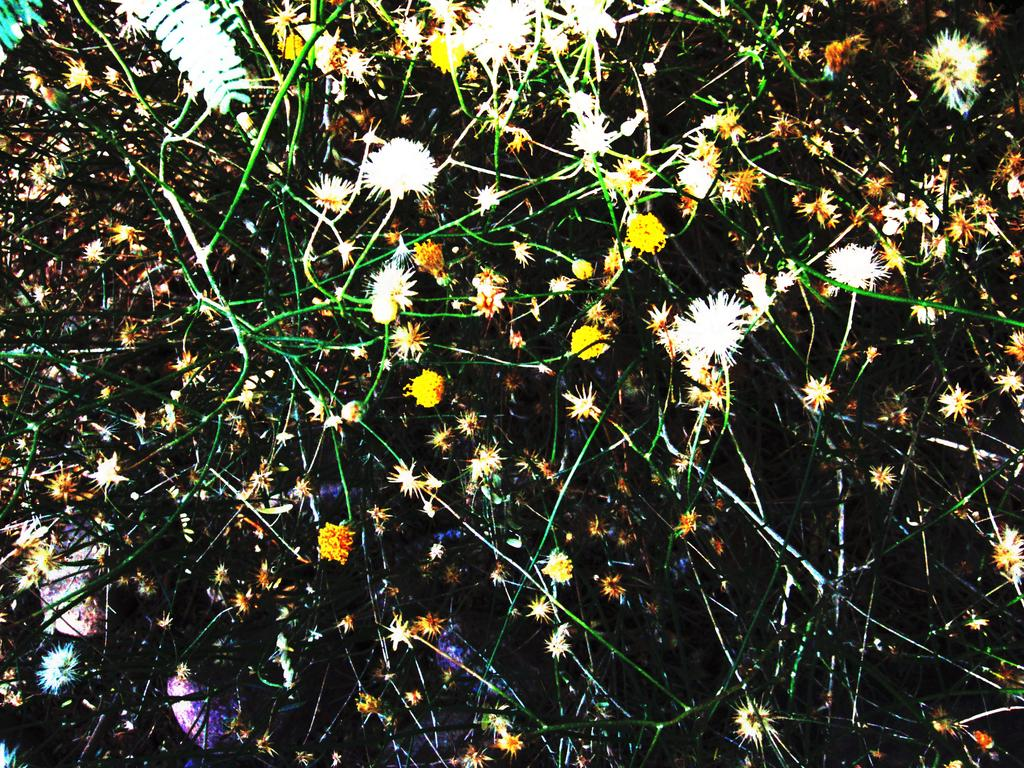What type of plant life is visible in the image? There are flowers, stems, and leaves in the image. Can you describe the different parts of the plants in the image? The flowers are the colorful parts of the plants, the stems are the long, thin structures that support the flowers, and the leaves are the flat, green parts that help the plants absorb sunlight. Who is the creator of the bottle seen in the image? There is no bottle present in the image, so it is not possible to determine who its creator might be. 